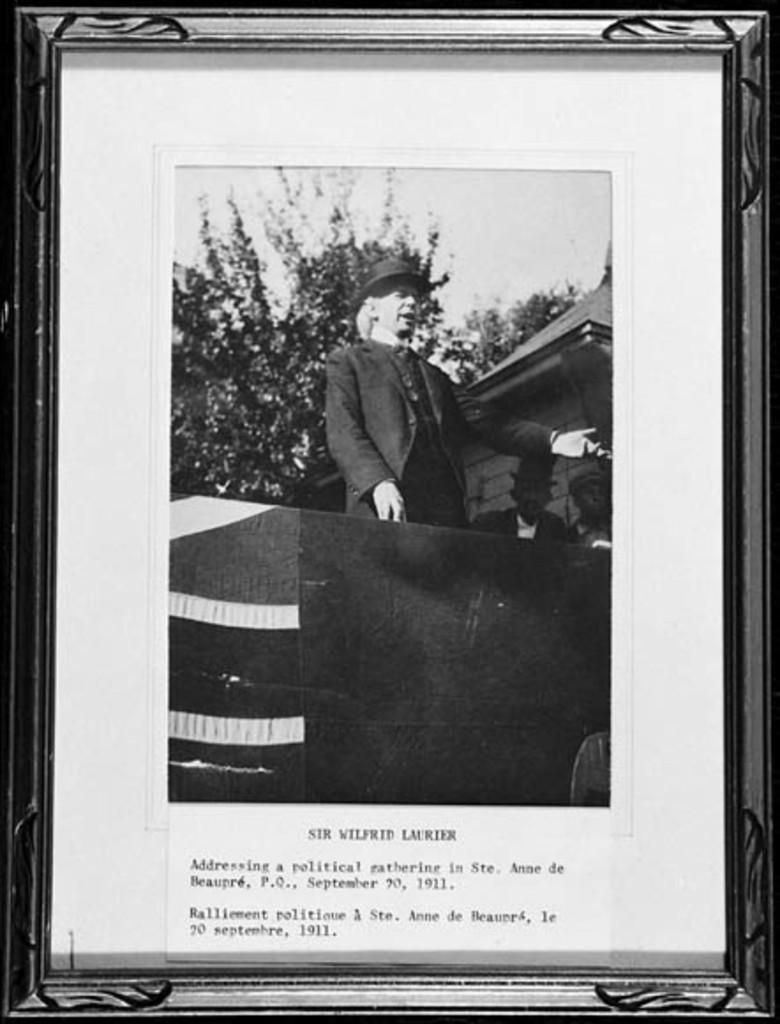Provide a one-sentence caption for the provided image. A framed black and white photo is titled Sir Wilfrid Laurier. 